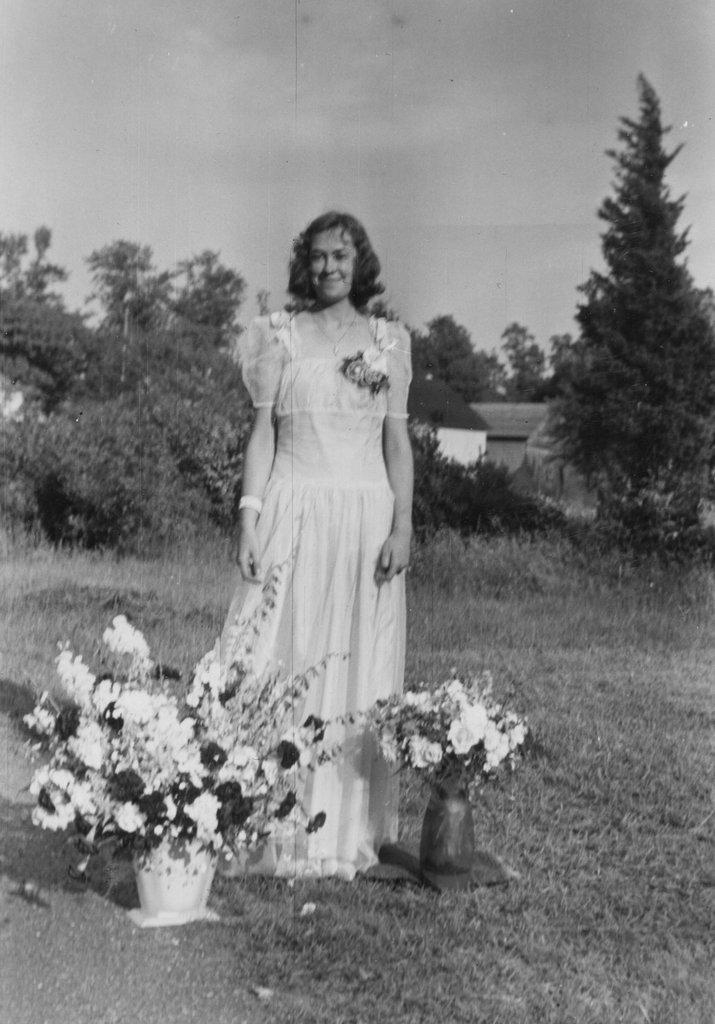How would you summarize this image in a sentence or two? In the middle of the image we can see a woman, she is smiling, beside to her we can find few flower vases, in the background we can see few trees and houses and it is a black and white photograph. 